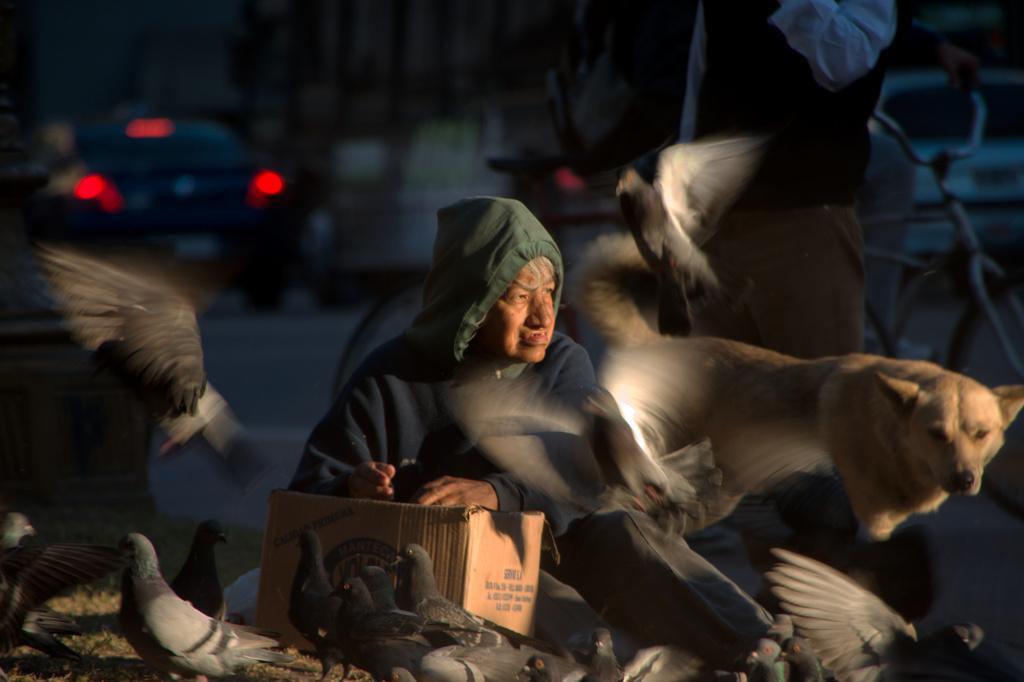Could you give a brief overview of what you see in this image? In this image, we can see an old person holding a carton box and sitting. Beside him, there is a dog and person. In the middle of the image, we can see few birds flying in the air. In the background, we can see the blur view, a person riding a bicycle and vehicles on the road. At the bottom of the image, we can see grass and birds. 